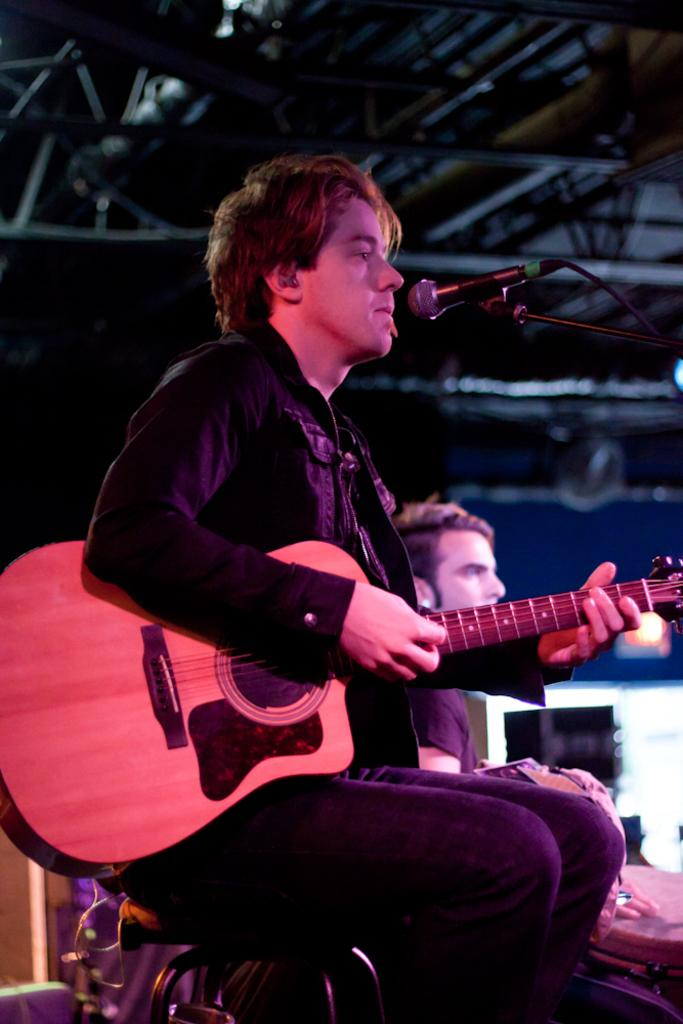What is the man in the image doing while sitting on the chair? The man is playing the guitar. What object is the man holding while playing the guitar? The man is holding a guitar. Where is the man positioned in relation to the microphone? The man is in front of a microphone. Can you describe the presence of another person in the image? There is another man sitting on a chair on the right side of the image. What architectural feature is visible in the image? There is a roof visible in the image. What type of wax is being used to create the melody in the image? There is no wax present in the image, and the melody is being created by the man playing the guitar. What type of pleasure can be seen on the faces of the men in the image? There is no indication of the men's emotions or pleasure in the image. 